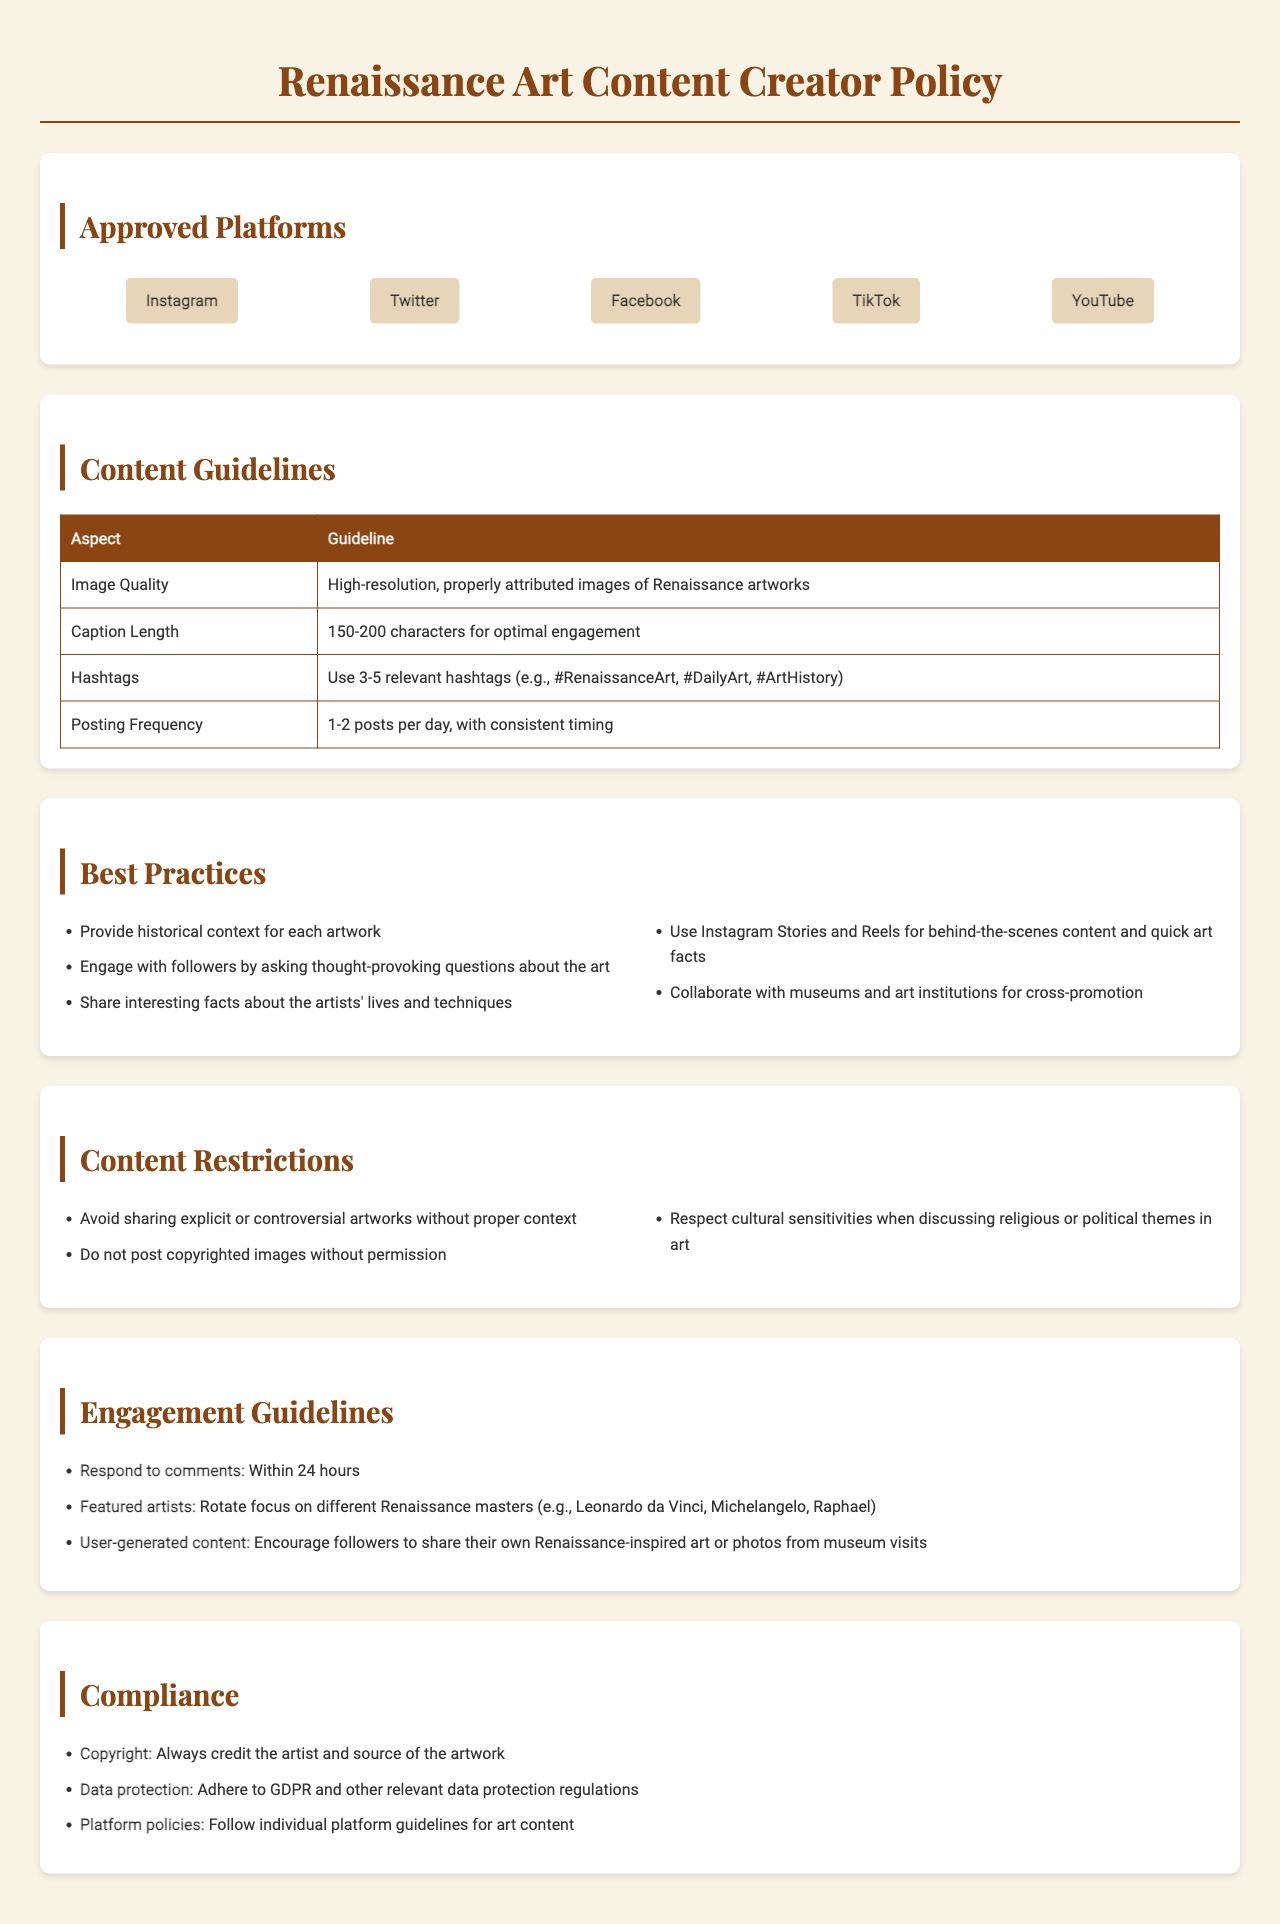What are the approved platforms for sharing content? The approved platforms are listed in the document under "Approved Platforms."
Answer: Instagram, Twitter, Facebook, TikTok, YouTube What is the optimal caption length for posts? The optimal caption length is specified in the "Content Guidelines" section.
Answer: 150-200 characters How many posts should be made per day according to the guidelines? The posting frequency is detailed under "Content Guidelines."
Answer: 1-2 posts per day What is a best practice for enhancing follower engagement? The best practices include recommendations that encourage engagement; one is found in the "Best Practices" section.
Answer: Engage with followers by asking thought-provoking questions What should be avoided when sharing art content? The content restrictions indicate specific things to avoid, one of which is stated clearly.
Answer: Avoid sharing explicit or controversial artworks without proper context How long should comments be responded to? The engagement guideline states a specific time frame for responding to comments.
Answer: Within 24 hours What is required regarding copyright compliance? Compliance requirements are outlined under "Compliance," detailing how to handle credits.
Answer: Always credit the artist and source of the artwork How many relevant hashtags should be used? The number of relevant hashtags is specified in "Content Guidelines."
Answer: 3-5 relevant hashtags What is an example of a platform policy guideline? Individual platform guidelines for art content are mentioned under "Compliance."
Answer: Follow individual platform guidelines for art content 